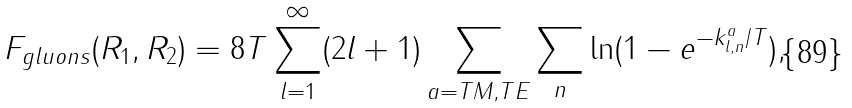<formula> <loc_0><loc_0><loc_500><loc_500>F _ { g l u o n s } ( R _ { 1 } , R _ { 2 } ) = 8 T \sum _ { l = 1 } ^ { \infty } ( 2 l + 1 ) \sum _ { a = T M , T E } \sum _ { n } \ln ( 1 - e ^ { - k _ { l , n } ^ { a } / T } ) ,</formula> 